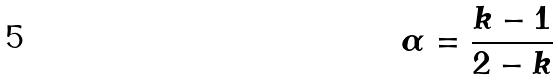Convert formula to latex. <formula><loc_0><loc_0><loc_500><loc_500>\alpha = \frac { k - 1 } { 2 - k }</formula> 